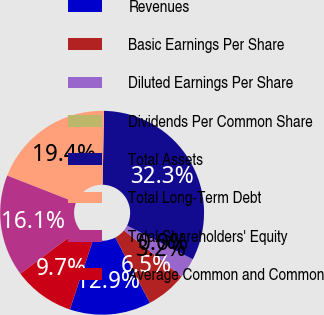Convert chart. <chart><loc_0><loc_0><loc_500><loc_500><pie_chart><fcel>Revenues<fcel>Basic Earnings Per Share<fcel>Diluted Earnings Per Share<fcel>Dividends Per Common Share<fcel>Total Assets<fcel>Total Long-Term Debt<fcel>Total Shareholders' Equity<fcel>Average Common and Common<nl><fcel>12.9%<fcel>6.45%<fcel>3.23%<fcel>0.0%<fcel>32.25%<fcel>19.35%<fcel>16.13%<fcel>9.68%<nl></chart> 